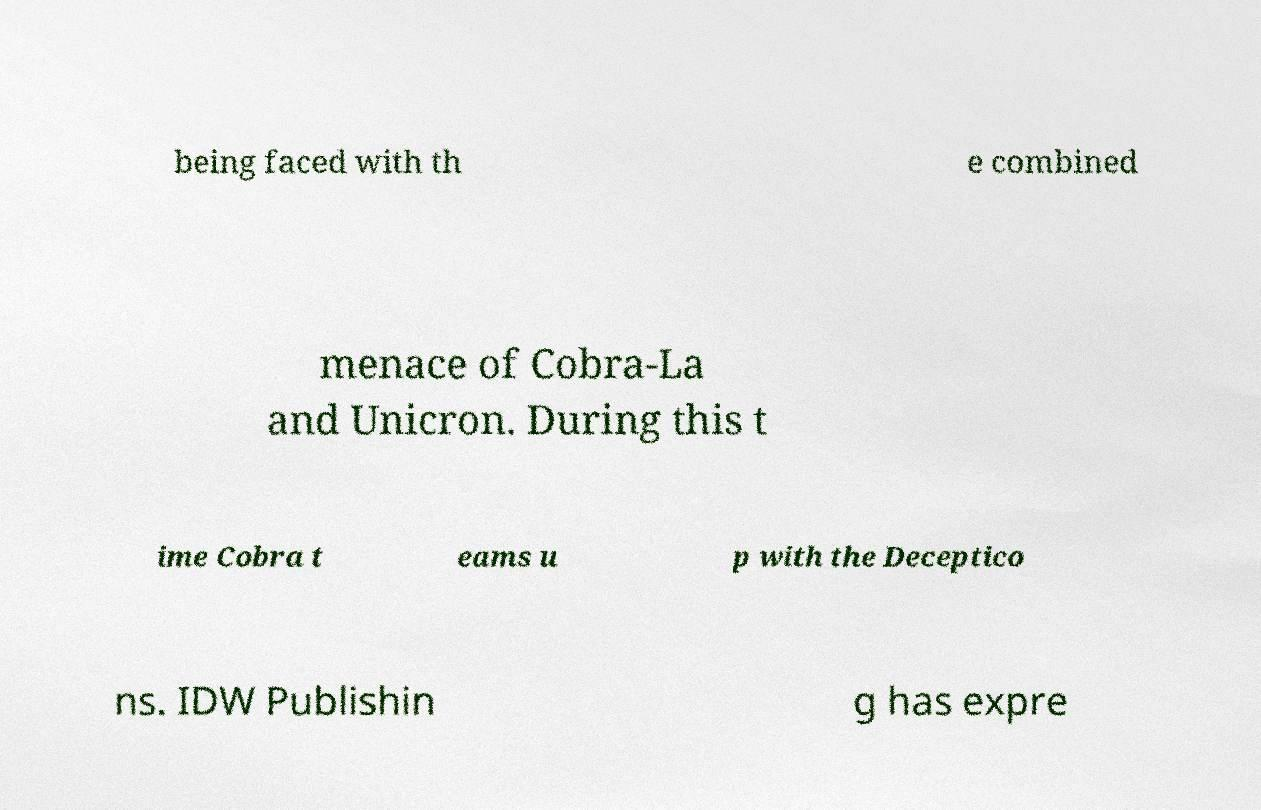Please identify and transcribe the text found in this image. being faced with th e combined menace of Cobra-La and Unicron. During this t ime Cobra t eams u p with the Deceptico ns. IDW Publishin g has expre 